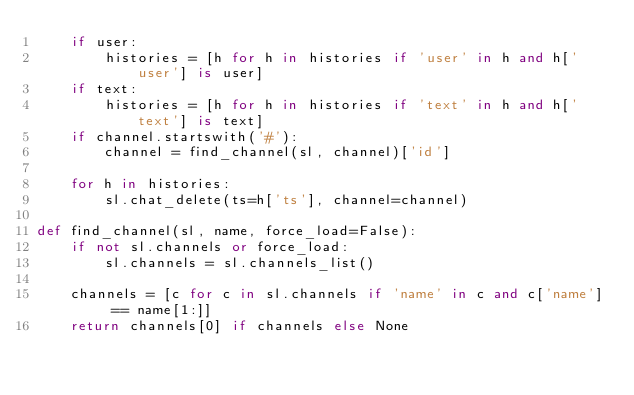<code> <loc_0><loc_0><loc_500><loc_500><_Python_>    if user:
        histories = [h for h in histories if 'user' in h and h['user'] is user]
    if text:
        histories = [h for h in histories if 'text' in h and h['text'] is text]
    if channel.startswith('#'):
        channel = find_channel(sl, channel)['id']

    for h in histories:
        sl.chat_delete(ts=h['ts'], channel=channel)

def find_channel(sl, name, force_load=False):
    if not sl.channels or force_load:
        sl.channels = sl.channels_list()

    channels = [c for c in sl.channels if 'name' in c and c['name'] == name[1:]]
    return channels[0] if channels else None
</code> 